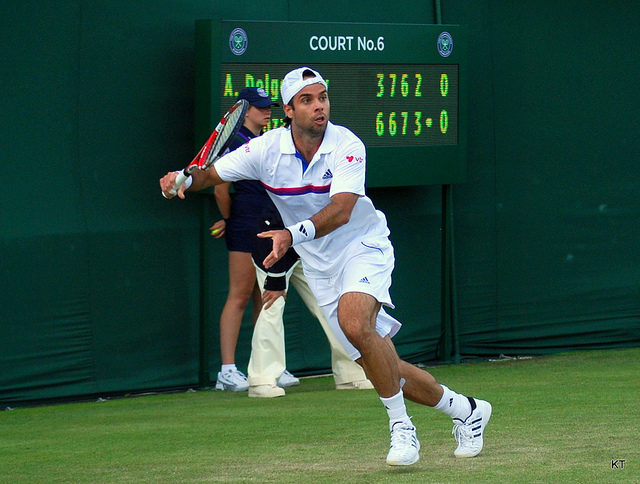Identify the text displayed in this image. KT 6673 0 3 7 6 2 .6 No. COURT 